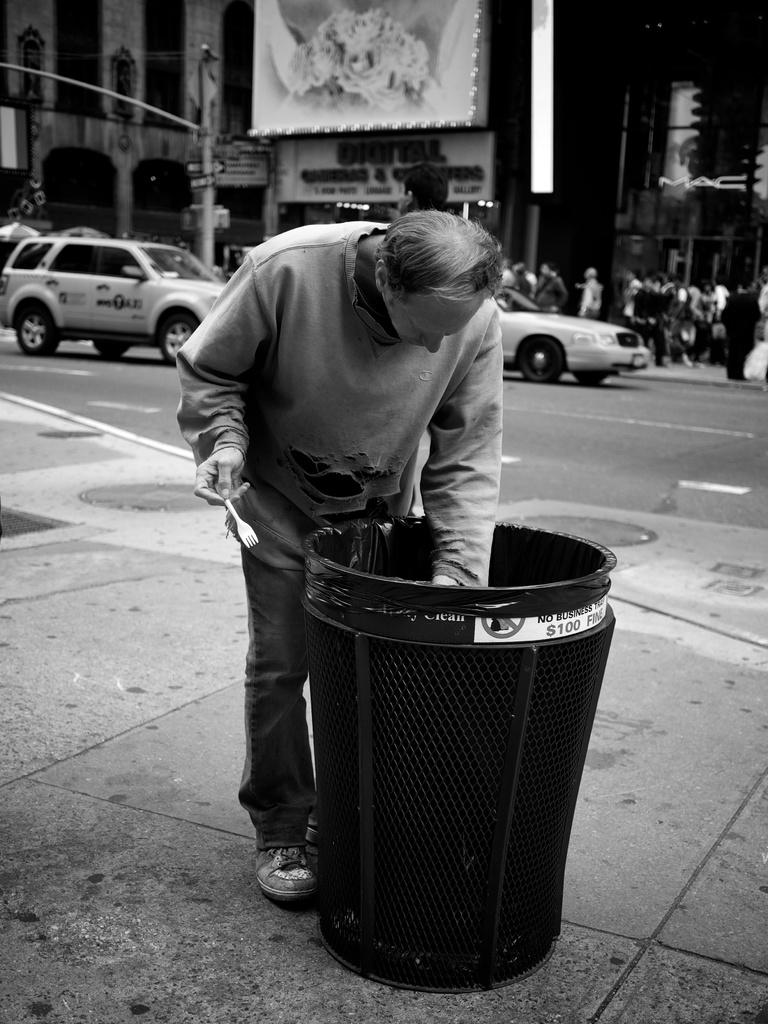Provide a one-sentence caption for the provided image. A man digging in a trash can with a sticker on it saying no business trash or $100 fine. 